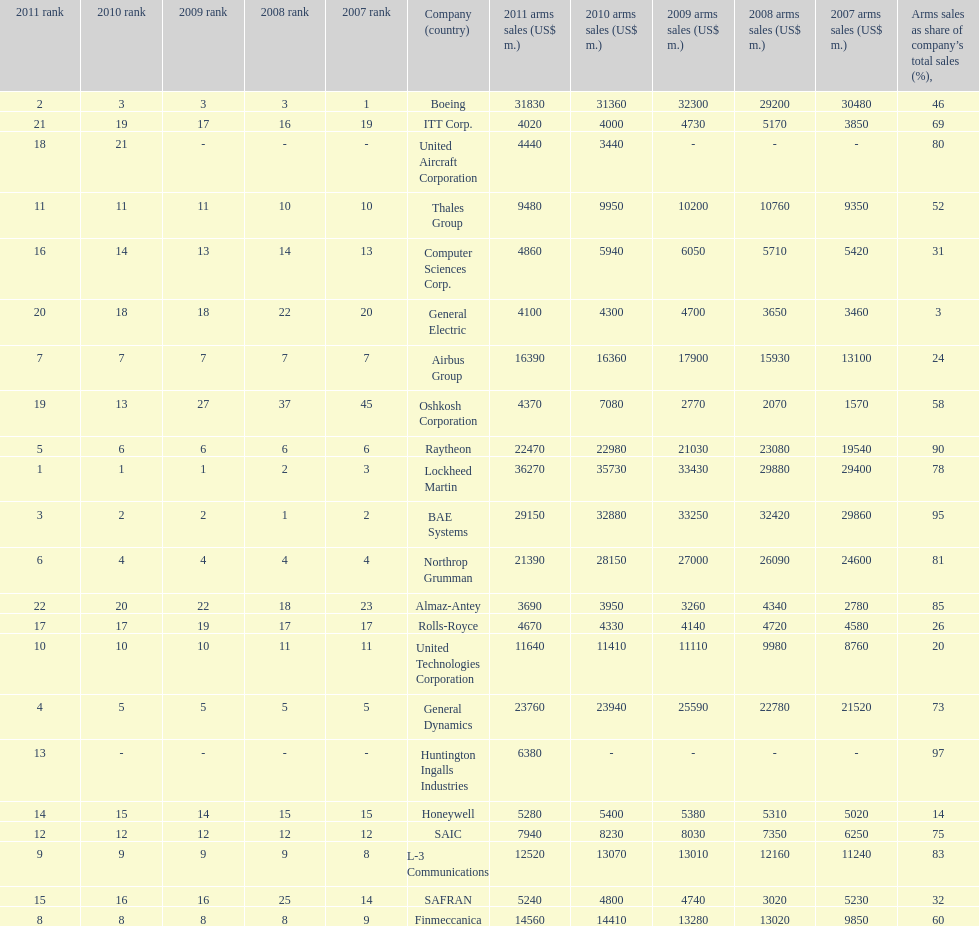How many different countries are listed? 6. 